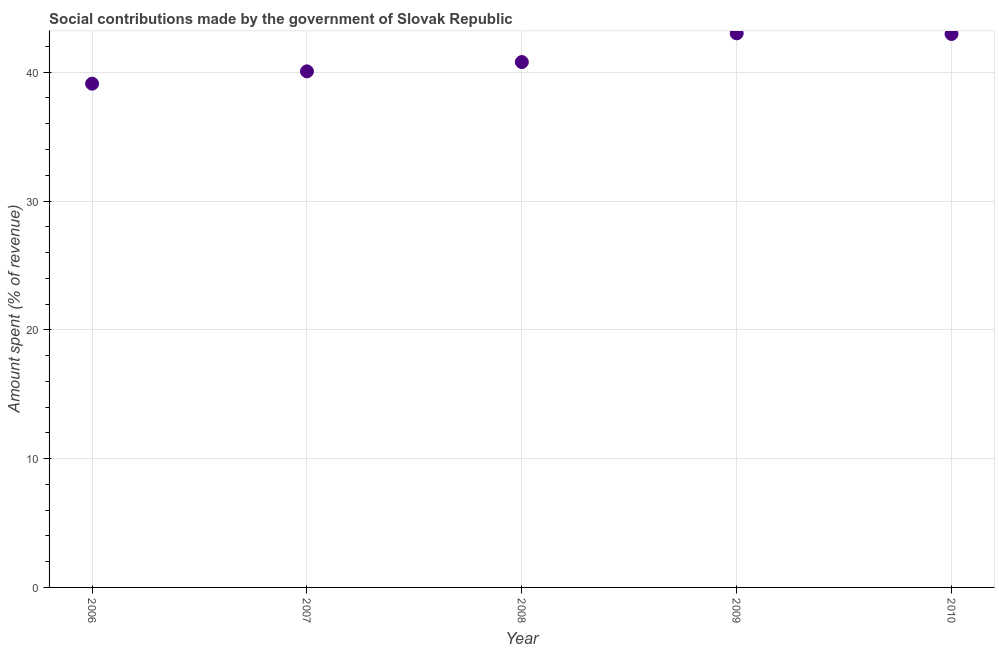What is the amount spent in making social contributions in 2010?
Your answer should be compact. 42.97. Across all years, what is the maximum amount spent in making social contributions?
Ensure brevity in your answer.  43.02. Across all years, what is the minimum amount spent in making social contributions?
Your answer should be very brief. 39.11. In which year was the amount spent in making social contributions maximum?
Keep it short and to the point. 2009. What is the sum of the amount spent in making social contributions?
Make the answer very short. 205.95. What is the difference between the amount spent in making social contributions in 2006 and 2007?
Your response must be concise. -0.96. What is the average amount spent in making social contributions per year?
Your answer should be very brief. 41.19. What is the median amount spent in making social contributions?
Ensure brevity in your answer.  40.79. In how many years, is the amount spent in making social contributions greater than 20 %?
Your response must be concise. 5. What is the ratio of the amount spent in making social contributions in 2006 to that in 2009?
Your response must be concise. 0.91. Is the amount spent in making social contributions in 2009 less than that in 2010?
Your answer should be compact. No. What is the difference between the highest and the second highest amount spent in making social contributions?
Give a very brief answer. 0.05. Is the sum of the amount spent in making social contributions in 2007 and 2008 greater than the maximum amount spent in making social contributions across all years?
Your answer should be compact. Yes. What is the difference between the highest and the lowest amount spent in making social contributions?
Offer a very short reply. 3.91. Does the amount spent in making social contributions monotonically increase over the years?
Offer a terse response. No. How many dotlines are there?
Provide a succinct answer. 1. Are the values on the major ticks of Y-axis written in scientific E-notation?
Make the answer very short. No. Does the graph contain any zero values?
Provide a short and direct response. No. Does the graph contain grids?
Your answer should be very brief. Yes. What is the title of the graph?
Keep it short and to the point. Social contributions made by the government of Slovak Republic. What is the label or title of the X-axis?
Ensure brevity in your answer.  Year. What is the label or title of the Y-axis?
Give a very brief answer. Amount spent (% of revenue). What is the Amount spent (% of revenue) in 2006?
Keep it short and to the point. 39.11. What is the Amount spent (% of revenue) in 2007?
Your answer should be compact. 40.07. What is the Amount spent (% of revenue) in 2008?
Offer a terse response. 40.79. What is the Amount spent (% of revenue) in 2009?
Keep it short and to the point. 43.02. What is the Amount spent (% of revenue) in 2010?
Ensure brevity in your answer.  42.97. What is the difference between the Amount spent (% of revenue) in 2006 and 2007?
Offer a very short reply. -0.96. What is the difference between the Amount spent (% of revenue) in 2006 and 2008?
Offer a very short reply. -1.68. What is the difference between the Amount spent (% of revenue) in 2006 and 2009?
Offer a terse response. -3.91. What is the difference between the Amount spent (% of revenue) in 2006 and 2010?
Your answer should be compact. -3.86. What is the difference between the Amount spent (% of revenue) in 2007 and 2008?
Your response must be concise. -0.72. What is the difference between the Amount spent (% of revenue) in 2007 and 2009?
Ensure brevity in your answer.  -2.95. What is the difference between the Amount spent (% of revenue) in 2007 and 2010?
Keep it short and to the point. -2.9. What is the difference between the Amount spent (% of revenue) in 2008 and 2009?
Your answer should be compact. -2.23. What is the difference between the Amount spent (% of revenue) in 2008 and 2010?
Provide a succinct answer. -2.18. What is the difference between the Amount spent (% of revenue) in 2009 and 2010?
Make the answer very short. 0.05. What is the ratio of the Amount spent (% of revenue) in 2006 to that in 2008?
Provide a succinct answer. 0.96. What is the ratio of the Amount spent (% of revenue) in 2006 to that in 2009?
Keep it short and to the point. 0.91. What is the ratio of the Amount spent (% of revenue) in 2006 to that in 2010?
Offer a very short reply. 0.91. What is the ratio of the Amount spent (% of revenue) in 2007 to that in 2008?
Provide a short and direct response. 0.98. What is the ratio of the Amount spent (% of revenue) in 2007 to that in 2009?
Ensure brevity in your answer.  0.93. What is the ratio of the Amount spent (% of revenue) in 2007 to that in 2010?
Your response must be concise. 0.93. What is the ratio of the Amount spent (% of revenue) in 2008 to that in 2009?
Offer a terse response. 0.95. What is the ratio of the Amount spent (% of revenue) in 2008 to that in 2010?
Offer a very short reply. 0.95. What is the ratio of the Amount spent (% of revenue) in 2009 to that in 2010?
Offer a terse response. 1. 